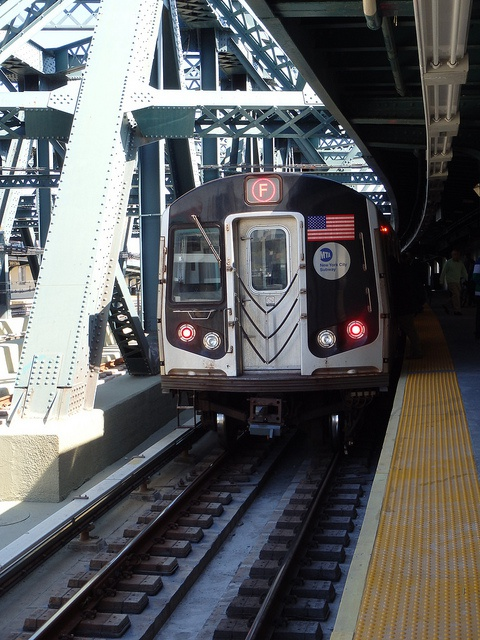Describe the objects in this image and their specific colors. I can see train in blue, black, gray, darkgray, and lightgray tones and people in black and blue tones in this image. 